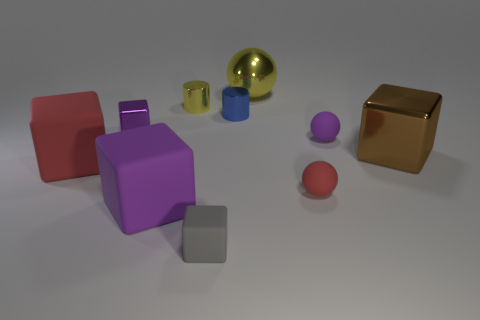What is the big sphere behind the brown metal cube made of?
Offer a terse response. Metal. What number of yellow objects are either shiny spheres or tiny matte things?
Ensure brevity in your answer.  1. Are the red ball and the small cube in front of the tiny purple rubber object made of the same material?
Offer a very short reply. Yes. Are there an equal number of brown things behind the small purple ball and blue objects right of the brown metallic thing?
Offer a very short reply. Yes. There is a yellow ball; is it the same size as the purple cube that is behind the red ball?
Your answer should be compact. No. Is the number of red objects on the right side of the small metal block greater than the number of green rubber cylinders?
Provide a succinct answer. Yes. How many purple matte objects have the same size as the brown block?
Your answer should be very brief. 1. Is the size of the matte object behind the brown cube the same as the yellow metallic thing that is on the left side of the gray rubber cube?
Give a very brief answer. Yes. Is the number of purple matte things in front of the large brown metallic thing greater than the number of tiny gray rubber cubes to the right of the large yellow thing?
Your response must be concise. Yes. How many other yellow shiny objects are the same shape as the tiny yellow thing?
Offer a very short reply. 0. 